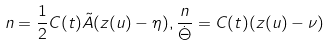<formula> <loc_0><loc_0><loc_500><loc_500>n = \frac { 1 } { 2 } C ( t ) \tilde { A } ( z ( u ) - \eta ) , \frac { n } { \dot { \Theta } } = C ( t ) ( z ( u ) - \nu )</formula> 